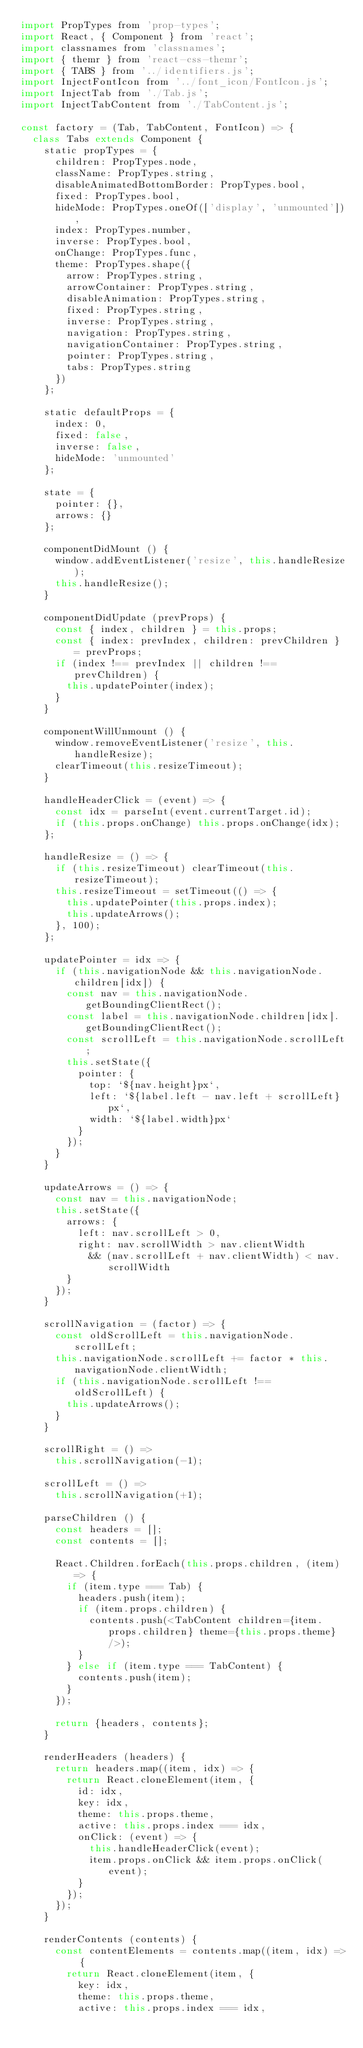Convert code to text. <code><loc_0><loc_0><loc_500><loc_500><_JavaScript_>import PropTypes from 'prop-types';
import React, { Component } from 'react';
import classnames from 'classnames';
import { themr } from 'react-css-themr';
import { TABS } from '../identifiers.js';
import InjectFontIcon from '../font_icon/FontIcon.js';
import InjectTab from './Tab.js';
import InjectTabContent from './TabContent.js';

const factory = (Tab, TabContent, FontIcon) => {
  class Tabs extends Component {
    static propTypes = {
      children: PropTypes.node,
      className: PropTypes.string,
      disableAnimatedBottomBorder: PropTypes.bool,
      fixed: PropTypes.bool,
      hideMode: PropTypes.oneOf(['display', 'unmounted']),
      index: PropTypes.number,
      inverse: PropTypes.bool,
      onChange: PropTypes.func,
      theme: PropTypes.shape({
        arrow: PropTypes.string,
        arrowContainer: PropTypes.string,
        disableAnimation: PropTypes.string,
        fixed: PropTypes.string,
        inverse: PropTypes.string,
        navigation: PropTypes.string,
        navigationContainer: PropTypes.string,
        pointer: PropTypes.string,
        tabs: PropTypes.string
      })
    };

    static defaultProps = {
      index: 0,
      fixed: false,
      inverse: false,
      hideMode: 'unmounted'
    };

    state = {
      pointer: {},
      arrows: {}
    };

    componentDidMount () {
      window.addEventListener('resize', this.handleResize);
      this.handleResize();
    }

    componentDidUpdate (prevProps) {
      const { index, children } = this.props;
      const { index: prevIndex, children: prevChildren } = prevProps;
      if (index !== prevIndex || children !== prevChildren) {
        this.updatePointer(index);
      }
    }

    componentWillUnmount () {
      window.removeEventListener('resize', this.handleResize);
      clearTimeout(this.resizeTimeout);
    }

    handleHeaderClick = (event) => {
      const idx = parseInt(event.currentTarget.id);
      if (this.props.onChange) this.props.onChange(idx);
    };

    handleResize = () => {
      if (this.resizeTimeout) clearTimeout(this.resizeTimeout);
      this.resizeTimeout = setTimeout(() => {
        this.updatePointer(this.props.index);
        this.updateArrows();
      }, 100);
    };

    updatePointer = idx => {
      if (this.navigationNode && this.navigationNode.children[idx]) {
        const nav = this.navigationNode.getBoundingClientRect();
        const label = this.navigationNode.children[idx].getBoundingClientRect();
        const scrollLeft = this.navigationNode.scrollLeft;
        this.setState({
          pointer: {
            top: `${nav.height}px`,
            left: `${label.left - nav.left + scrollLeft}px`,
            width: `${label.width}px`
          }
        });
      }
    }

    updateArrows = () => {
      const nav = this.navigationNode;
      this.setState({
        arrows: {
          left: nav.scrollLeft > 0,
          right: nav.scrollWidth > nav.clientWidth
            && (nav.scrollLeft + nav.clientWidth) < nav.scrollWidth
        }
      });
    }

    scrollNavigation = (factor) => {
      const oldScrollLeft = this.navigationNode.scrollLeft;
      this.navigationNode.scrollLeft += factor * this.navigationNode.clientWidth;
      if (this.navigationNode.scrollLeft !== oldScrollLeft) {
        this.updateArrows();
      }
    }

    scrollRight = () =>
      this.scrollNavigation(-1);

    scrollLeft = () =>
      this.scrollNavigation(+1);

    parseChildren () {
      const headers = [];
      const contents = [];

      React.Children.forEach(this.props.children, (item) => {
        if (item.type === Tab) {
          headers.push(item);
          if (item.props.children) {
            contents.push(<TabContent children={item.props.children} theme={this.props.theme} />);
          }
        } else if (item.type === TabContent) {
          contents.push(item);
        }
      });

      return {headers, contents};
    }

    renderHeaders (headers) {
      return headers.map((item, idx) => {
        return React.cloneElement(item, {
          id: idx,
          key: idx,
          theme: this.props.theme,
          active: this.props.index === idx,
          onClick: (event) => {
            this.handleHeaderClick(event);
            item.props.onClick && item.props.onClick(event);
          }
        });
      });
    }

    renderContents (contents) {
      const contentElements = contents.map((item, idx) => {
        return React.cloneElement(item, {
          key: idx,
          theme: this.props.theme,
          active: this.props.index === idx,</code> 